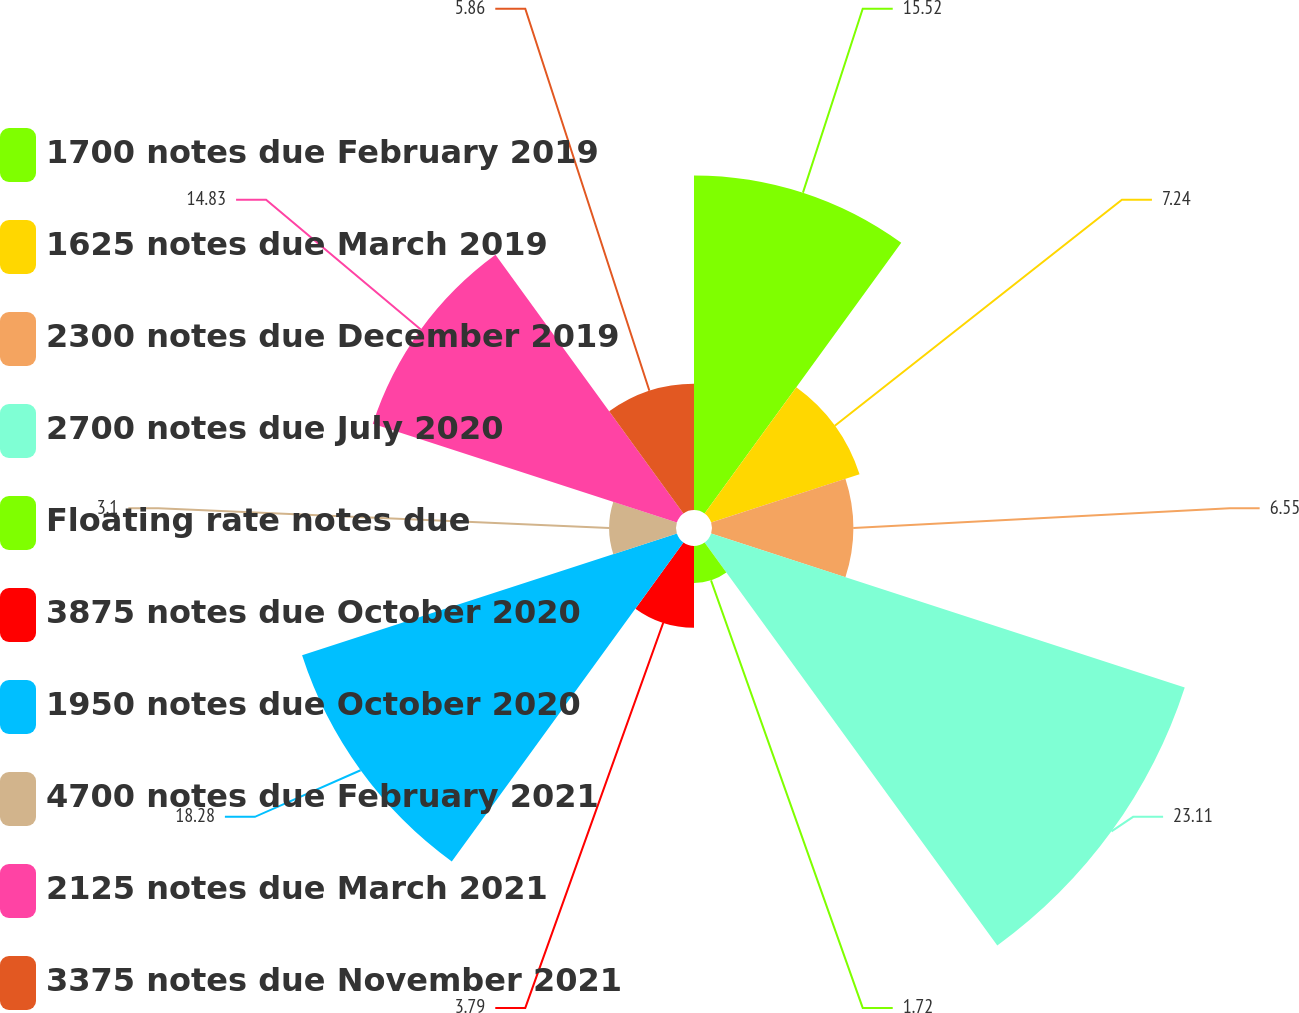<chart> <loc_0><loc_0><loc_500><loc_500><pie_chart><fcel>1700 notes due February 2019<fcel>1625 notes due March 2019<fcel>2300 notes due December 2019<fcel>2700 notes due July 2020<fcel>Floating rate notes due<fcel>3875 notes due October 2020<fcel>1950 notes due October 2020<fcel>4700 notes due February 2021<fcel>2125 notes due March 2021<fcel>3375 notes due November 2021<nl><fcel>15.52%<fcel>7.24%<fcel>6.55%<fcel>23.1%<fcel>1.72%<fcel>3.79%<fcel>18.28%<fcel>3.1%<fcel>14.83%<fcel>5.86%<nl></chart> 